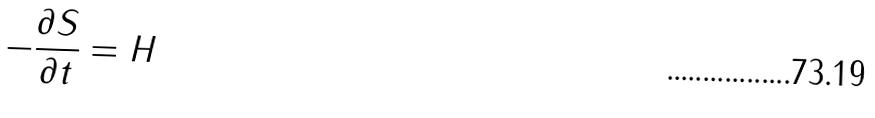Convert formula to latex. <formula><loc_0><loc_0><loc_500><loc_500>- \frac { \partial S } { \partial t } = H</formula> 